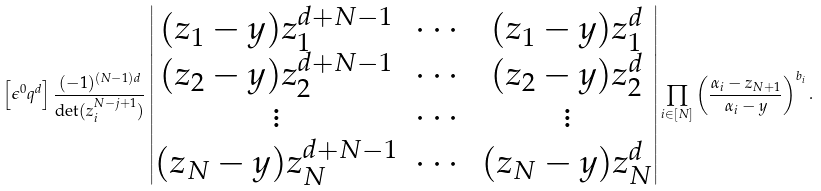<formula> <loc_0><loc_0><loc_500><loc_500>\left [ \epsilon ^ { 0 } q ^ { d } \right ] \frac { ( - 1 ) ^ { ( N - 1 ) d } } { \det ( z _ { i } ^ { N - j + 1 } ) } \begin{vmatrix} ( z _ { 1 } - y ) z _ { 1 } ^ { d + N - 1 } & \cdots & ( z _ { 1 } - y ) z _ { 1 } ^ { d } \\ ( z _ { 2 } - y ) z _ { 2 } ^ { d + N - 1 } & \cdots & ( z _ { 2 } - y ) z _ { 2 } ^ { d } \\ \vdots & \cdots & \vdots \\ ( z _ { N } - y ) z _ { N } ^ { d + N - 1 } & \cdots & ( z _ { N } - y ) z _ { N } ^ { d } \end{vmatrix} \prod _ { i \in [ N ] } \left ( \frac { \alpha _ { i } - z _ { N + 1 } } { \alpha _ { i } - y } \right ) ^ { b _ { i } } .</formula> 